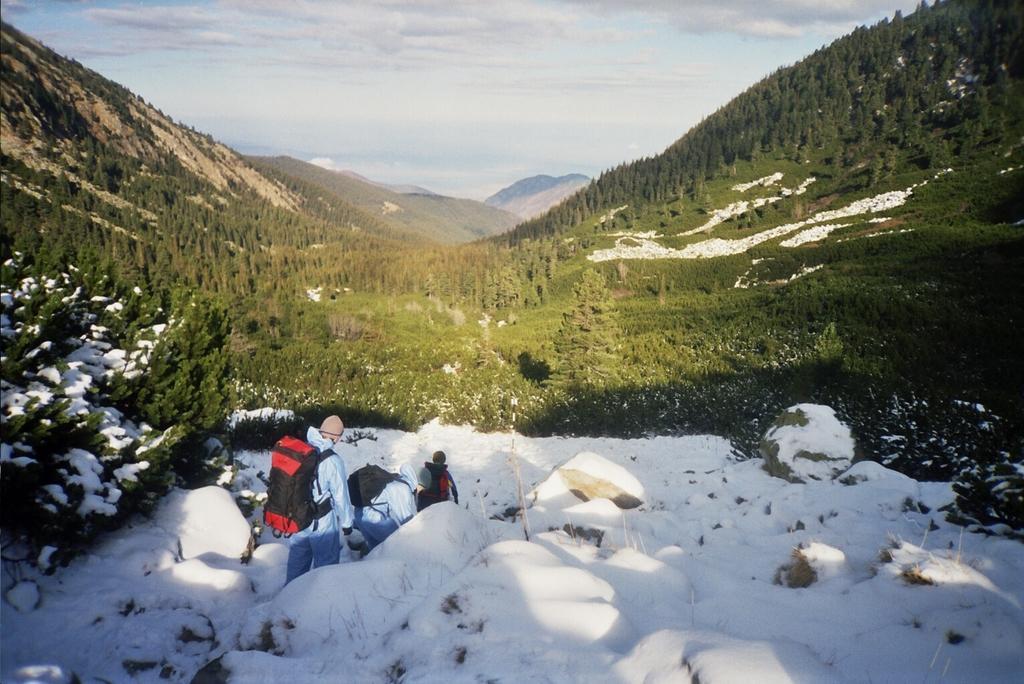Please provide a concise description of this image. In the picture we can see the snow surface with a man standing with a jacket and back bag and in front of him we can see two other people are standing and bending and near to the snow surface, we can see the grass surface with plants, trees and hills with trees and sky with clouds. 